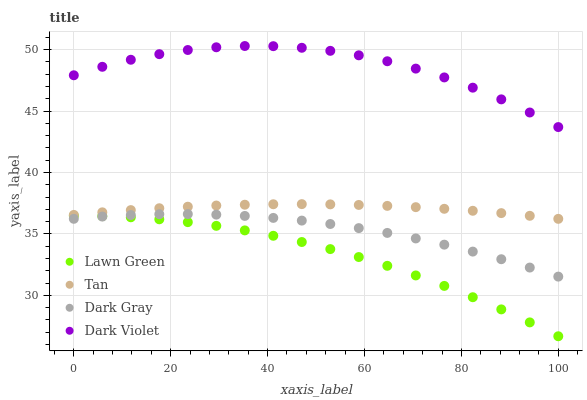Does Lawn Green have the minimum area under the curve?
Answer yes or no. Yes. Does Dark Violet have the maximum area under the curve?
Answer yes or no. Yes. Does Tan have the minimum area under the curve?
Answer yes or no. No. Does Tan have the maximum area under the curve?
Answer yes or no. No. Is Tan the smoothest?
Answer yes or no. Yes. Is Dark Violet the roughest?
Answer yes or no. Yes. Is Lawn Green the smoothest?
Answer yes or no. No. Is Lawn Green the roughest?
Answer yes or no. No. Does Lawn Green have the lowest value?
Answer yes or no. Yes. Does Tan have the lowest value?
Answer yes or no. No. Does Dark Violet have the highest value?
Answer yes or no. Yes. Does Tan have the highest value?
Answer yes or no. No. Is Tan less than Dark Violet?
Answer yes or no. Yes. Is Dark Violet greater than Dark Gray?
Answer yes or no. Yes. Does Lawn Green intersect Dark Gray?
Answer yes or no. Yes. Is Lawn Green less than Dark Gray?
Answer yes or no. No. Is Lawn Green greater than Dark Gray?
Answer yes or no. No. Does Tan intersect Dark Violet?
Answer yes or no. No. 